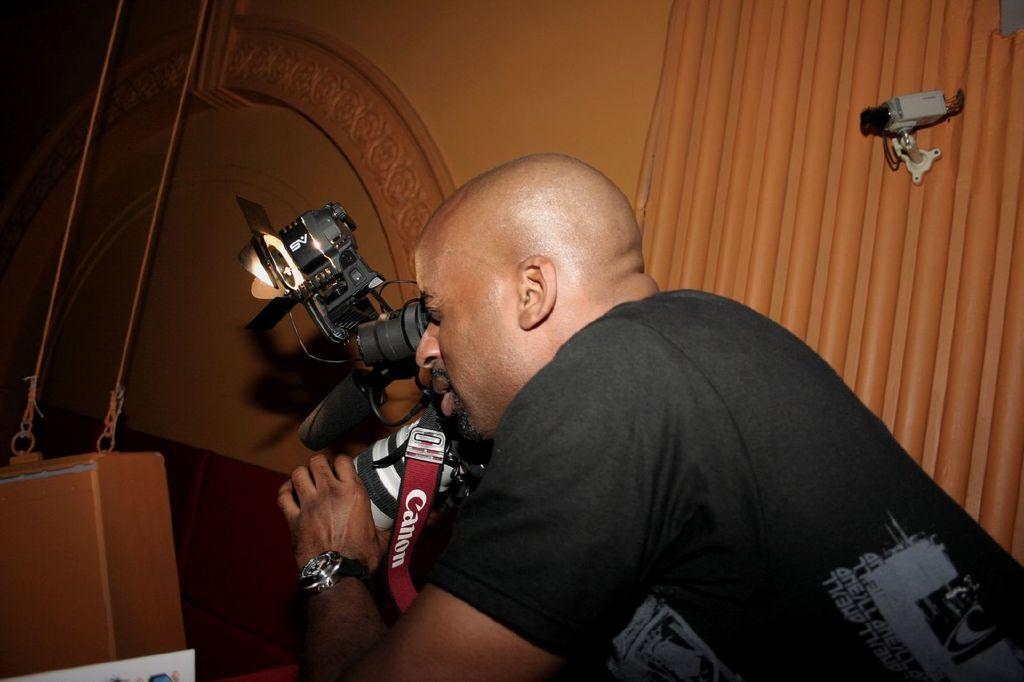Who is the person in the image? There is a man in the image. What is the man wearing? The man is wearing a black t-shirt. What is the man holding in the image? The man is holding a camera. Can you describe the camera? There is a tag attached to the camera. What else can be seen in the image? There is a CCTV on the wall in the image. What is the title of the book the man is reading in the image? There is no book present in the image; the man is holding a camera. 